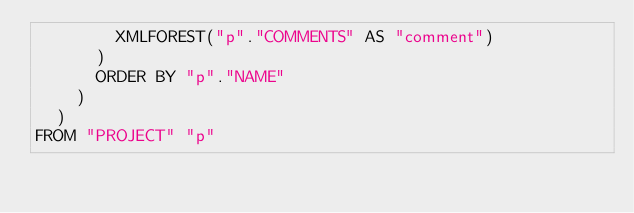Convert code to text. <code><loc_0><loc_0><loc_500><loc_500><_SQL_>        XMLFOREST("p"."COMMENTS" AS "comment")
      )
      ORDER BY "p"."NAME"
    )
  )
FROM "PROJECT" "p"</code> 